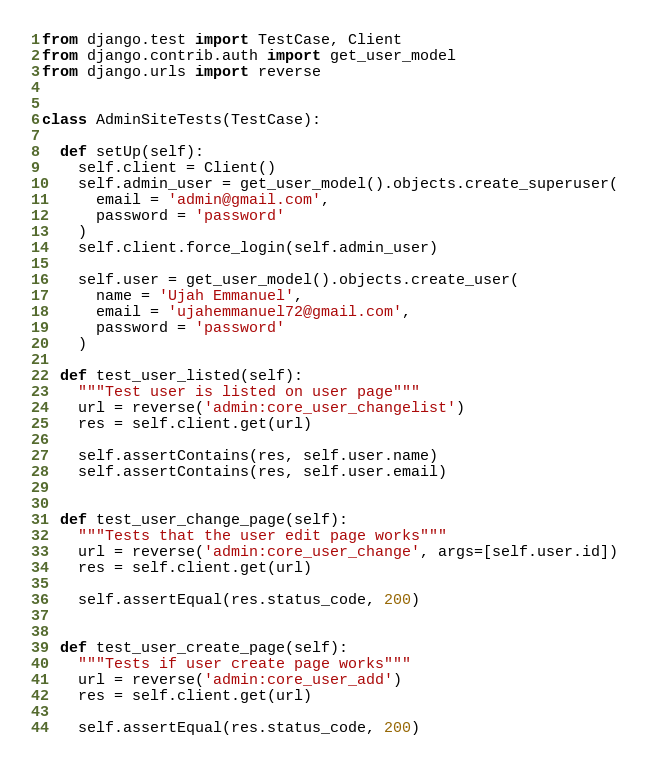<code> <loc_0><loc_0><loc_500><loc_500><_Python_>from django.test import TestCase, Client
from django.contrib.auth import get_user_model
from django.urls import reverse


class AdminSiteTests(TestCase):

  def setUp(self):
    self.client = Client()
    self.admin_user = get_user_model().objects.create_superuser(
      email = 'admin@gmail.com',
      password = 'password'
    )
    self.client.force_login(self.admin_user)

    self.user = get_user_model().objects.create_user(
      name = 'Ujah Emmanuel',
      email = 'ujahemmanuel72@gmail.com',
      password = 'password'
    )
  
  def test_user_listed(self):
    """Test user is listed on user page"""
    url = reverse('admin:core_user_changelist')
    res = self.client.get(url)

    self.assertContains(res, self.user.name)
    self.assertContains(res, self.user.email)

  
  def test_user_change_page(self):
    """Tests that the user edit page works"""
    url = reverse('admin:core_user_change', args=[self.user.id])
    res = self.client.get(url)

    self.assertEqual(res.status_code, 200)


  def test_user_create_page(self):
    """Tests if user create page works"""
    url = reverse('admin:core_user_add')
    res = self.client.get(url)

    self.assertEqual(res.status_code, 200)</code> 